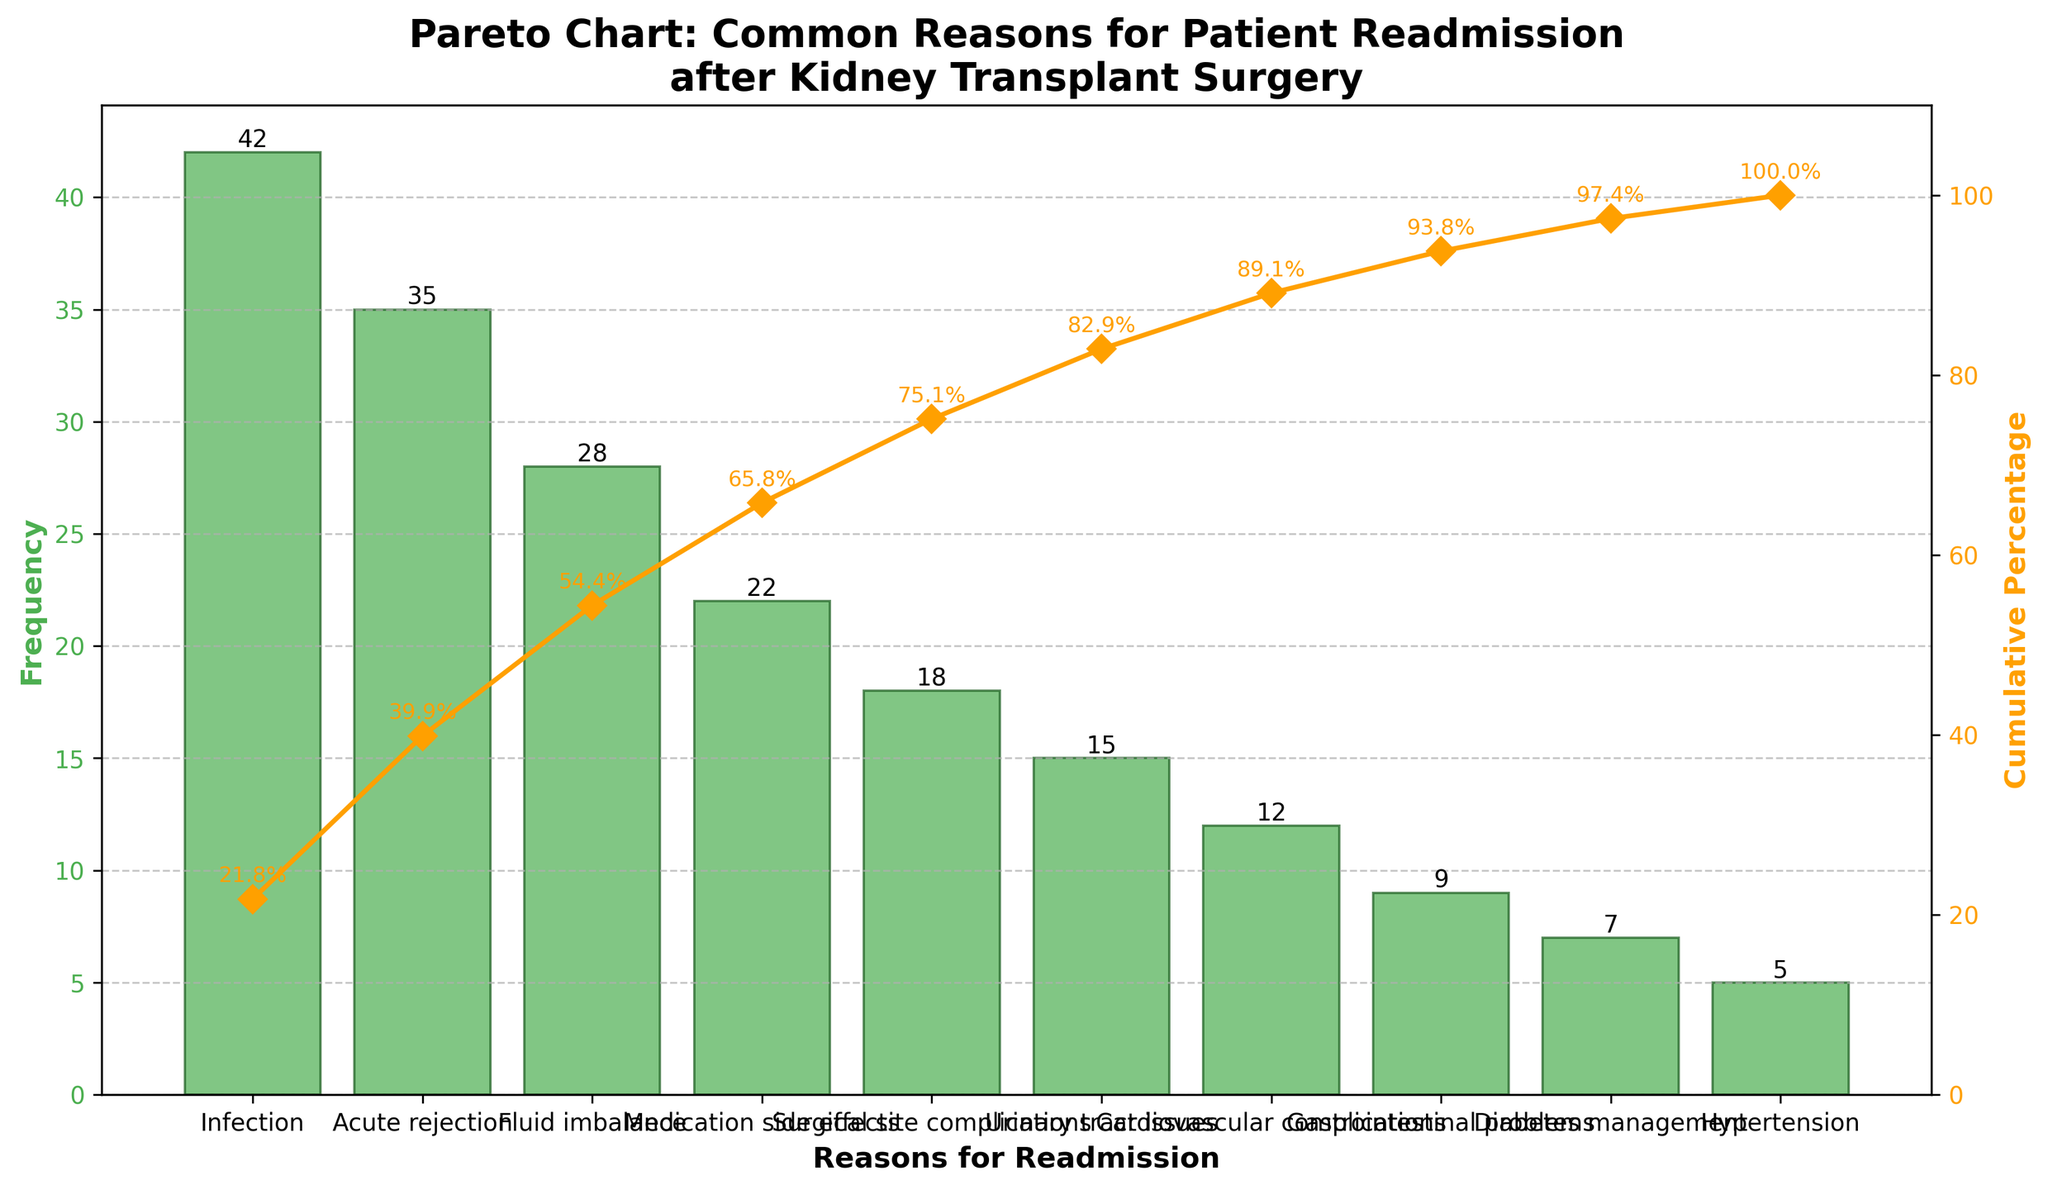What's the title of the Pareto chart? The title of a graph is usually located at the top of the chart and it succinctly describes what the chart is about. In this case, it should be easily readable.
Answer: Pareto Chart: Common Reasons for Patient Readmission after Kidney Transplant Surgery What are the axis labels for the bar chart and cumulative percentage line? The axis labels describe what each axis represents. For the bar chart, the x-axis label is found at the bottom, and the y-axis label is found to the left. For the cumulative percentage line, the y-axis label is on the right.
Answer: Reasons for Readmission, Frequency, Cumulative Percentage Which reason has the highest frequency of readmission? The reason with the highest frequency corresponds to the tallest bar in the bar chart.
Answer: Infection What is the cumulative percentage up to "Medication side effects"? To find this, you look at the line plot and see the cumulative percentage at the point corresponding to "Medication side effects."
Answer: 77.9% By how many frequencies does "Acute rejection" exceed "Fluid imbalance"? Subtract the frequency of "Fluid imbalance" from the frequency of "Acute rejection" to find the difference.
Answer: 7 Which has a higher frequency of readmission: "Urinary tract issues" or "Medication side effects"? Compare the heights of the bars corresponding to "Urinary tract issues" and "Medication side effects."
Answer: Medication side effects What percentage of readmissions do the top three reasons (Infection, Acute rejection, and Fluid imbalance) contribute? Sum the frequencies of the top three reasons and then divide by the total frequency to get their percentage.
Answer: 54.8% How many reasons have a frequency less than 10? Count the number of reasons with bars that represent frequencies below 10.
Answer: 3 When cumulative percentage exceeds 80%, which reasons are included? Identify the reasons that fall below the cumulative percentage line where it crosses 80%.
Answer: Infection, Acute rejection, Fluid imbalance, Medication side effects, Surgical site complications What frequency is represented at the third highest cumulative percentage point? Look at the bar with the third highest position in the cumulative percentage line to identify the corresponding frequency.
Answer: 28 